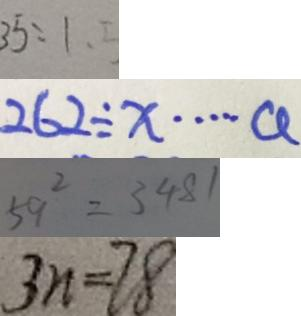<formula> <loc_0><loc_0><loc_500><loc_500>3 5 : 1 . 5 
 2 6 2 \div x \cdots a 
 5 9 ^ { 2 } = 3 4 8 1 
 3 n = 7 8</formula> 